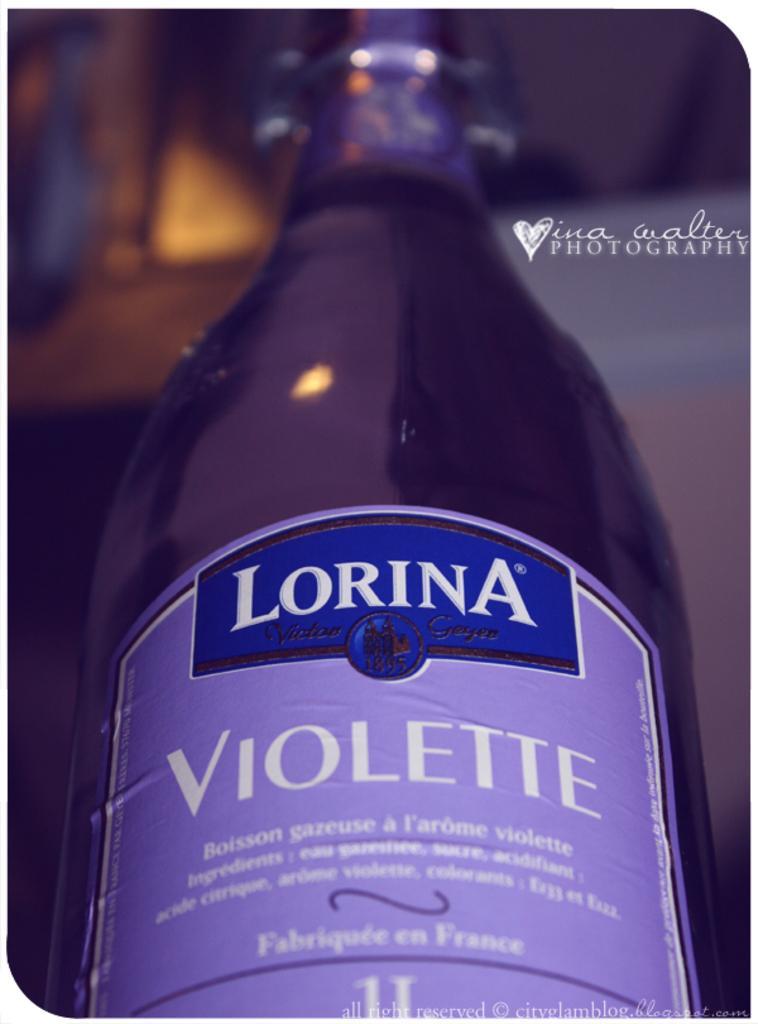How would you summarize this image in a sentence or two? In this image I can see a bottle. This bottle looks like a wine bottle. It is violet in color. And there is a label attached to the bottle. 